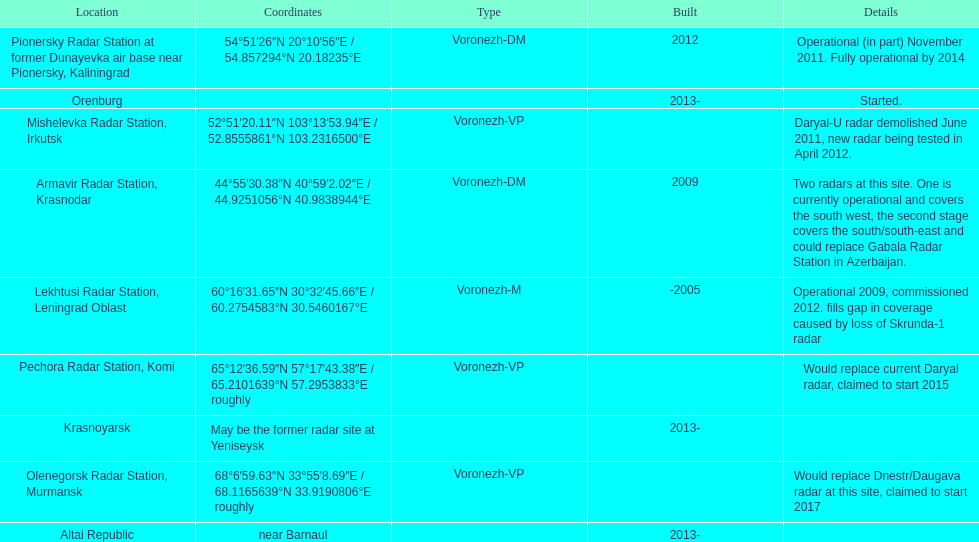How many voronezh radars are in kaliningrad or in krasnodar? 2. 